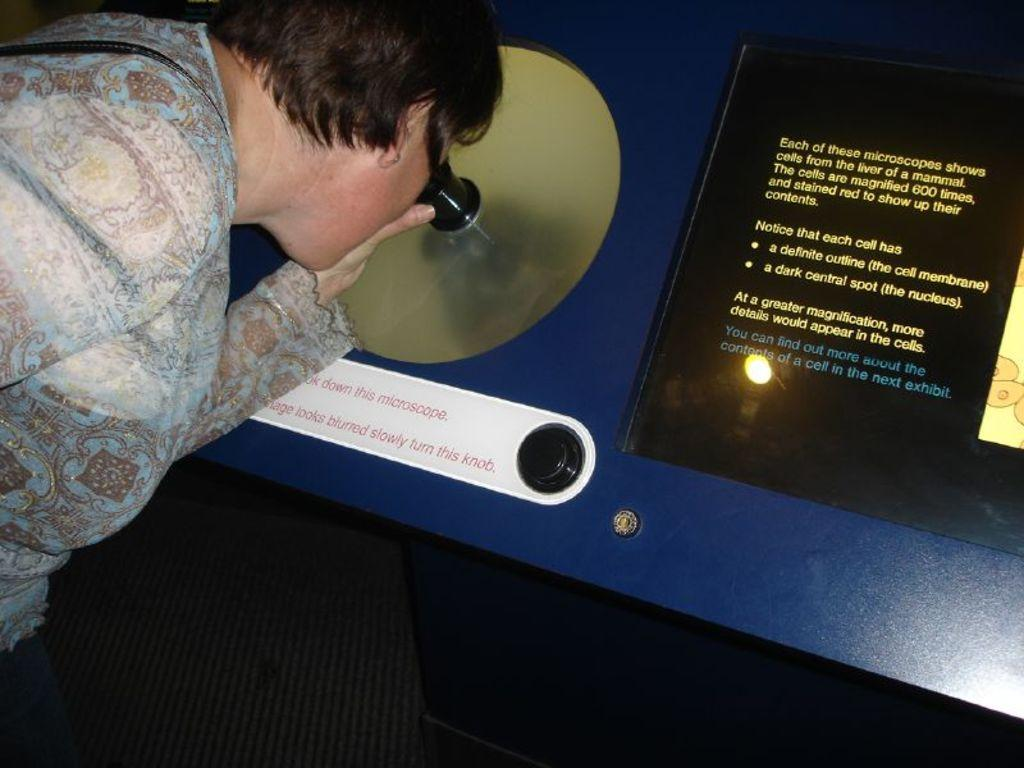Who is the main subject in the image? There is a woman in the image. What is the woman's situation in the image? The woman is locked into a hole. Can you describe the hole and its placement? The hole is placed on a board. What type of pump is being used by the woman's son in the image? There is no pump or son present in the image; it features a woman locked into a hole on a board. 